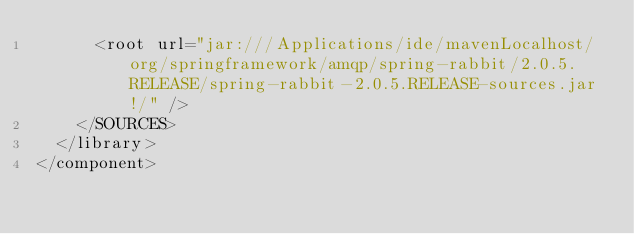Convert code to text. <code><loc_0><loc_0><loc_500><loc_500><_XML_>      <root url="jar:///Applications/ide/mavenLocalhost/org/springframework/amqp/spring-rabbit/2.0.5.RELEASE/spring-rabbit-2.0.5.RELEASE-sources.jar!/" />
    </SOURCES>
  </library>
</component></code> 